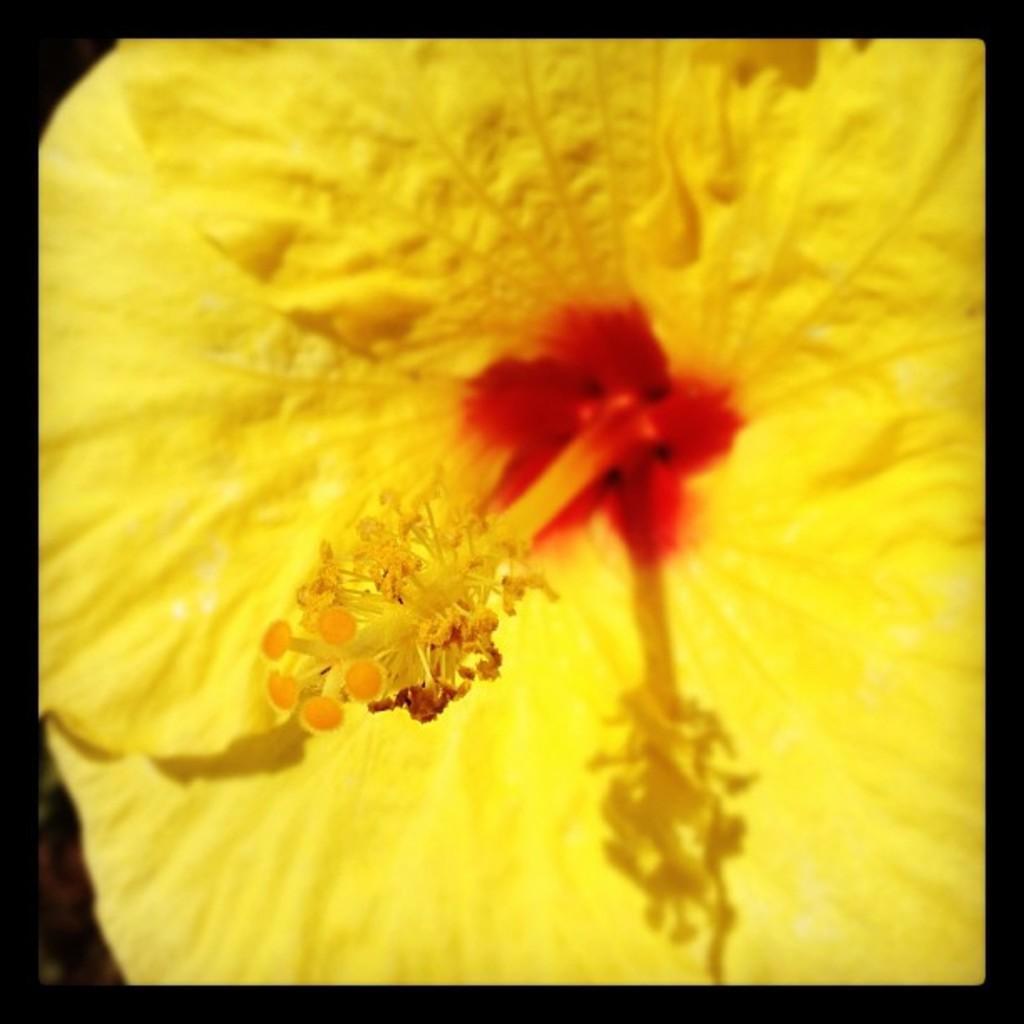Describe this image in one or two sentences. In this image there is a flower. In the center there are pollen grains. There are yellow petals in the image. There is black border around the image. 